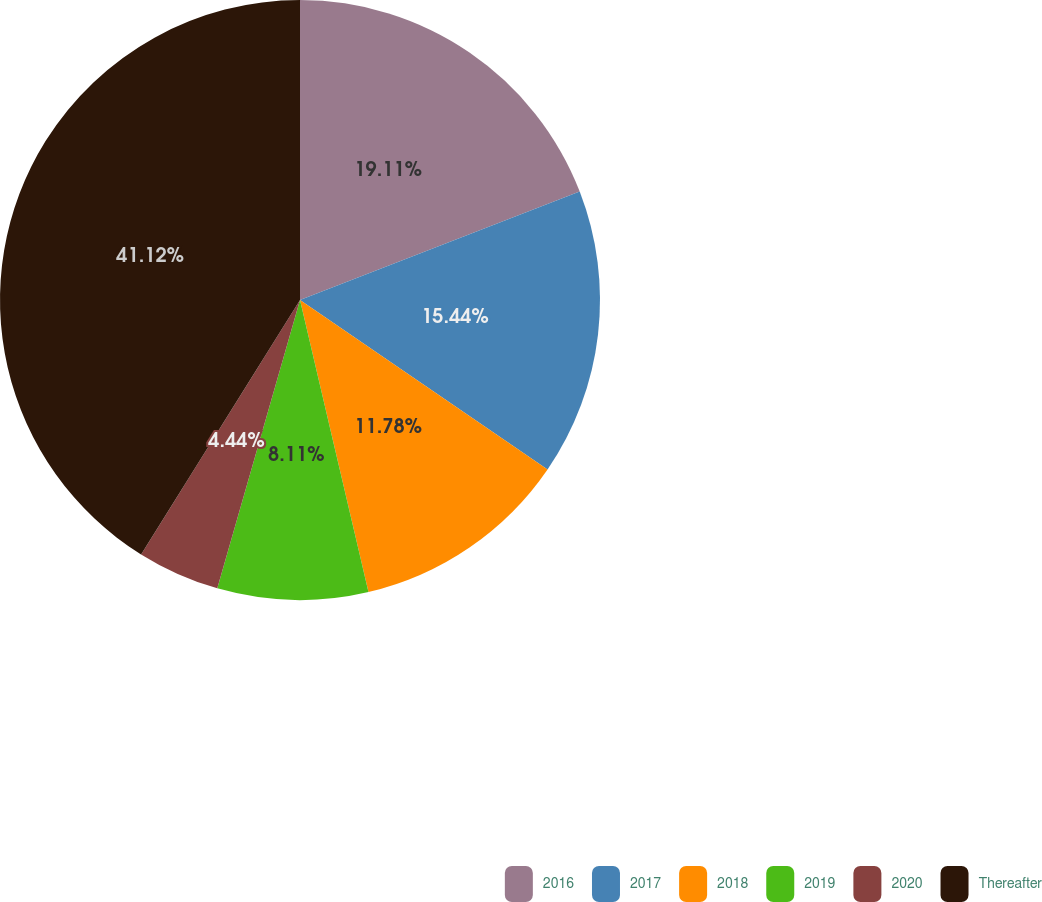Convert chart to OTSL. <chart><loc_0><loc_0><loc_500><loc_500><pie_chart><fcel>2016<fcel>2017<fcel>2018<fcel>2019<fcel>2020<fcel>Thereafter<nl><fcel>19.11%<fcel>15.44%<fcel>11.78%<fcel>8.11%<fcel>4.44%<fcel>41.11%<nl></chart> 